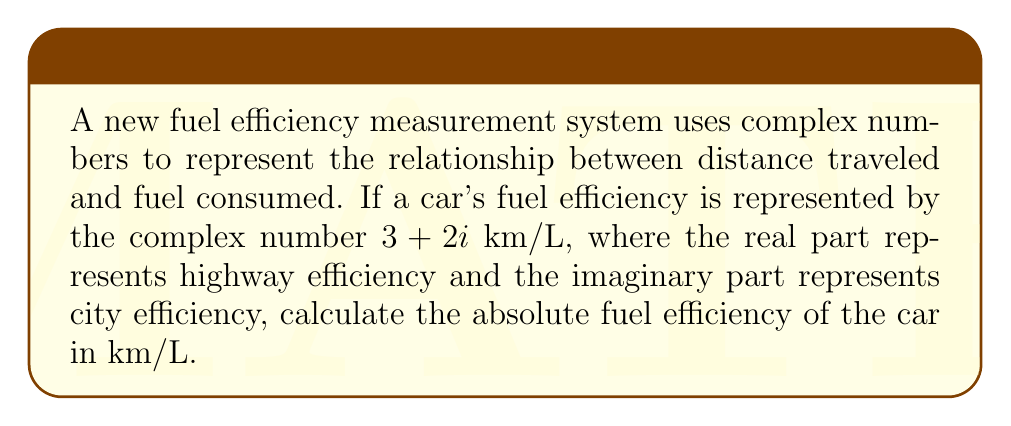Show me your answer to this math problem. To solve this problem, we need to follow these steps:

1. Understand the complex number representation:
   The fuel efficiency is given as $z = 3 + 2i$ km/L

2. Recall that the absolute value (magnitude) of a complex number $z = a + bi$ is given by:
   $|z| = \sqrt{a^2 + b^2}$

3. In our case:
   $a = 3$ (highway efficiency)
   $b = 2$ (city efficiency)

4. Apply the formula:
   $$|z| = \sqrt{3^2 + 2^2}$$

5. Simplify:
   $$|z| = \sqrt{9 + 4}$$
   $$|z| = \sqrt{13}$$

6. The result $\sqrt{13}$ km/L represents the absolute fuel efficiency, combining both highway and city efficiencies.
Answer: $\sqrt{13}$ km/L 